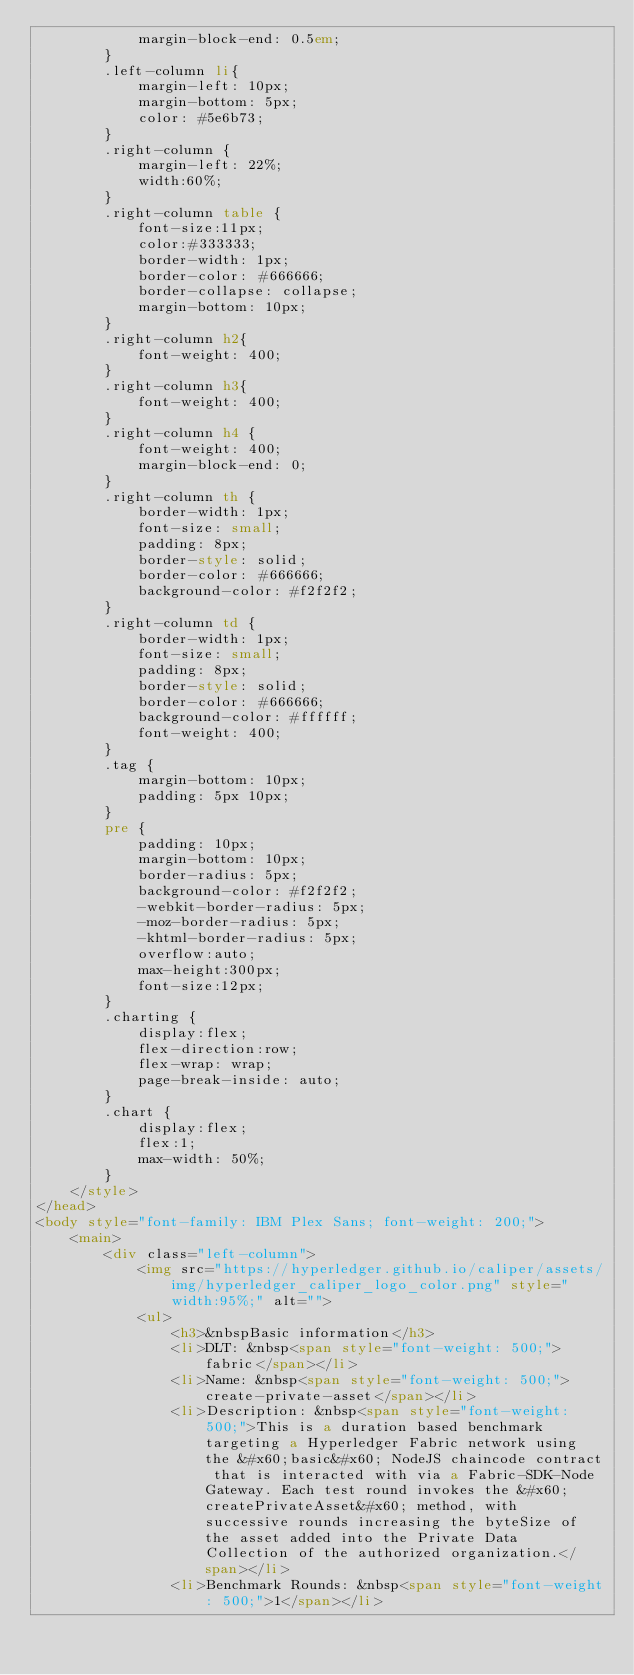Convert code to text. <code><loc_0><loc_0><loc_500><loc_500><_HTML_>            margin-block-end: 0.5em;
        }
        .left-column li{
            margin-left: 10px;
            margin-bottom: 5px;
            color: #5e6b73;
        }
        .right-column {
            margin-left: 22%;
            width:60%;
        }
        .right-column table {
            font-size:11px;
            color:#333333;
            border-width: 1px;
            border-color: #666666;
            border-collapse: collapse;
            margin-bottom: 10px;
        }
        .right-column h2{
            font-weight: 400;
        }
        .right-column h3{
            font-weight: 400;
        }
        .right-column h4 {
            font-weight: 400;
            margin-block-end: 0;
        }
        .right-column th {
            border-width: 1px;
            font-size: small;
            padding: 8px;
            border-style: solid;
            border-color: #666666;
            background-color: #f2f2f2;
        }
        .right-column td {
            border-width: 1px;
            font-size: small;
            padding: 8px;
            border-style: solid;
            border-color: #666666;
            background-color: #ffffff;
            font-weight: 400;
        }
        .tag {
            margin-bottom: 10px;
            padding: 5px 10px;
        }
        pre {
            padding: 10px;
            margin-bottom: 10px;
            border-radius: 5px;
            background-color: #f2f2f2;
            -webkit-border-radius: 5px;
            -moz-border-radius: 5px;
            -khtml-border-radius: 5px;
            overflow:auto;
            max-height:300px;
            font-size:12px;
        }
        .charting {
            display:flex;
            flex-direction:row;
            flex-wrap: wrap;
            page-break-inside: auto;
        }
        .chart {
            display:flex;
            flex:1;
            max-width: 50%;
        }
    </style>
</head>
<body style="font-family: IBM Plex Sans; font-weight: 200;">
    <main>
        <div class="left-column">
            <img src="https://hyperledger.github.io/caliper/assets/img/hyperledger_caliper_logo_color.png" style="width:95%;" alt="">
            <ul>
                <h3>&nbspBasic information</h3>
                <li>DLT: &nbsp<span style="font-weight: 500;">fabric</span></li>
                <li>Name: &nbsp<span style="font-weight: 500;">create-private-asset</span></li>
                <li>Description: &nbsp<span style="font-weight: 500;">This is a duration based benchmark targeting a Hyperledger Fabric network using the &#x60;basic&#x60; NodeJS chaincode contract that is interacted with via a Fabric-SDK-Node Gateway. Each test round invokes the &#x60;createPrivateAsset&#x60; method, with successive rounds increasing the byteSize of the asset added into the Private Data  Collection of the authorized organization.</span></li>
                <li>Benchmark Rounds: &nbsp<span style="font-weight: 500;">1</span></li></code> 